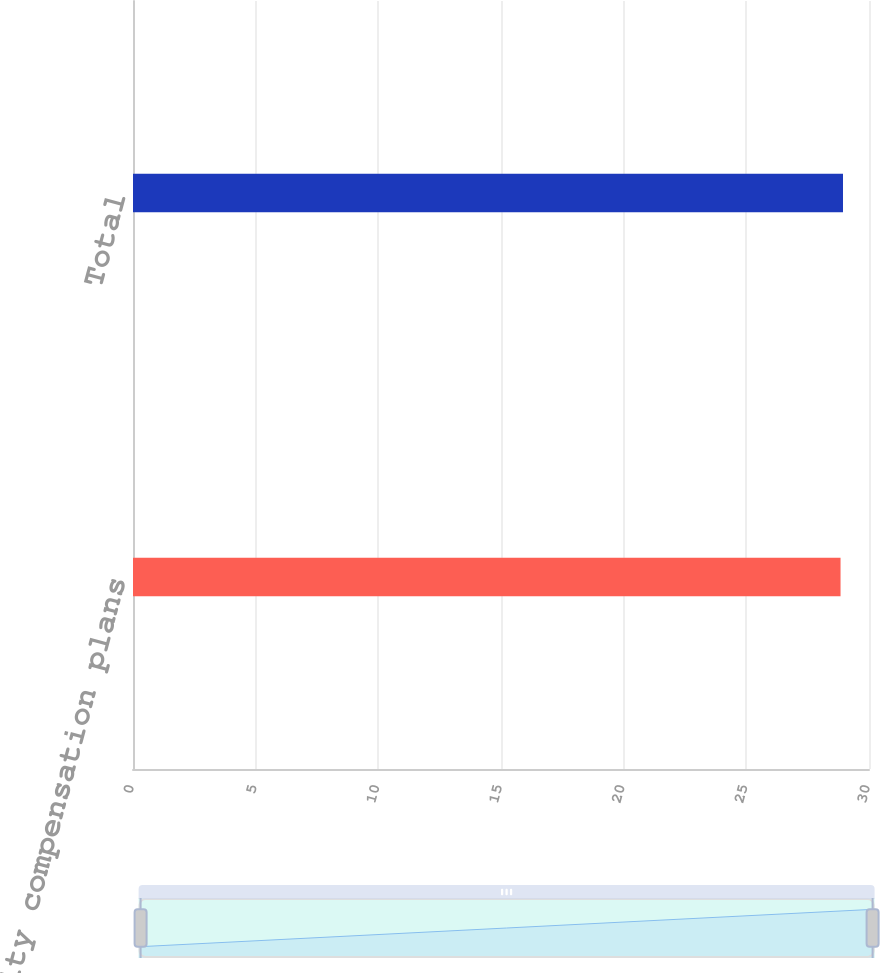<chart> <loc_0><loc_0><loc_500><loc_500><bar_chart><fcel>Equity compensation plans<fcel>Total<nl><fcel>28.84<fcel>28.94<nl></chart> 